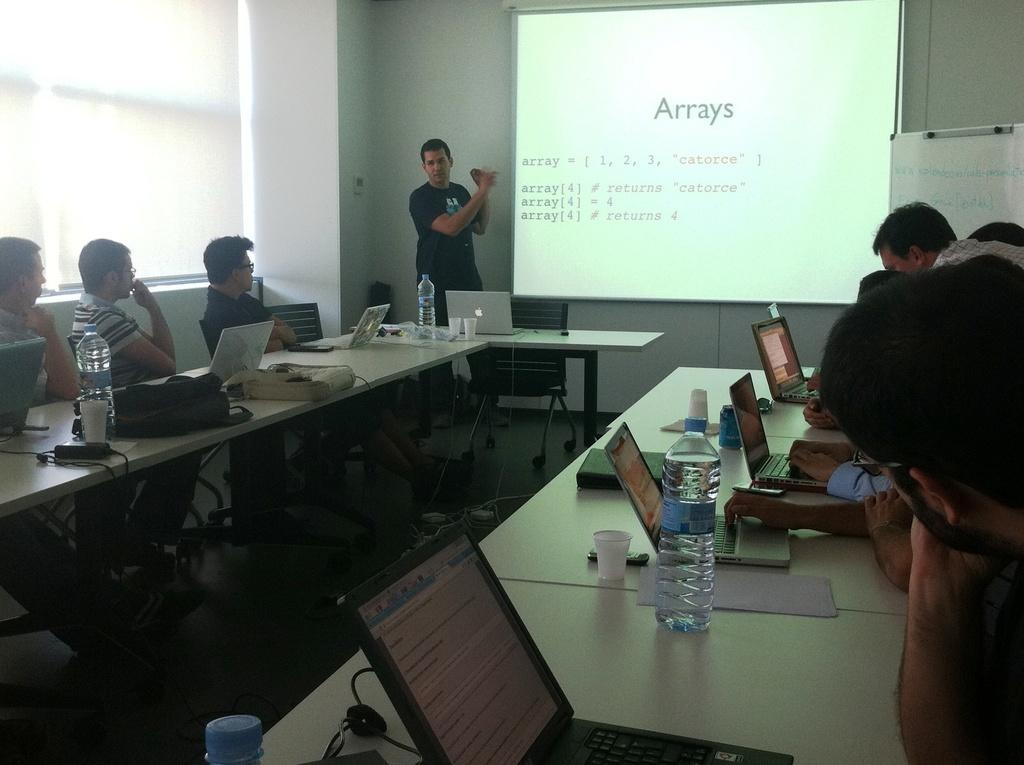<image>
Give a short and clear explanation of the subsequent image. the word arrays which is on a projected image 